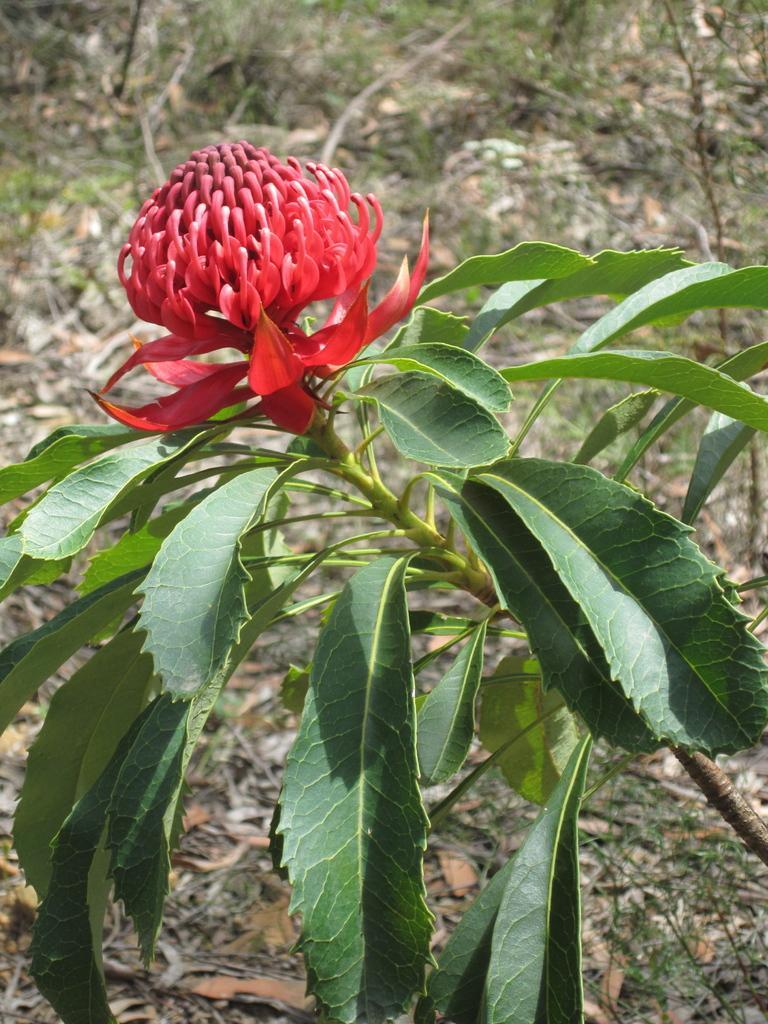Please provide a concise description of this image. In this picture there is a flower plant in the center of the image and the flower is red in color. 